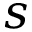<formula> <loc_0><loc_0><loc_500><loc_500>s</formula> 